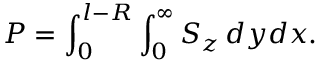<formula> <loc_0><loc_0><loc_500><loc_500>P = \int _ { 0 } ^ { l - R } \int _ { 0 } ^ { \infty } { S _ { z } \, d y d x } .</formula> 